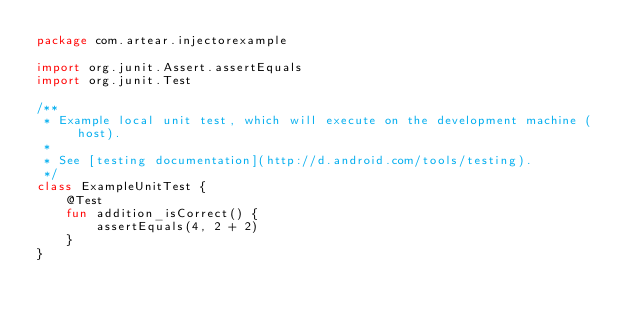Convert code to text. <code><loc_0><loc_0><loc_500><loc_500><_Kotlin_>package com.artear.injectorexample

import org.junit.Assert.assertEquals
import org.junit.Test

/**
 * Example local unit test, which will execute on the development machine (host).
 *
 * See [testing documentation](http://d.android.com/tools/testing).
 */
class ExampleUnitTest {
    @Test
    fun addition_isCorrect() {
        assertEquals(4, 2 + 2)
    }
}
</code> 